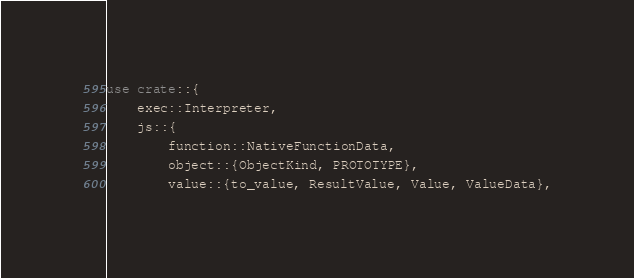<code> <loc_0><loc_0><loc_500><loc_500><_Rust_>use crate::{
    exec::Interpreter,
    js::{
        function::NativeFunctionData,
        object::{ObjectKind, PROTOTYPE},
        value::{to_value, ResultValue, Value, ValueData},</code> 